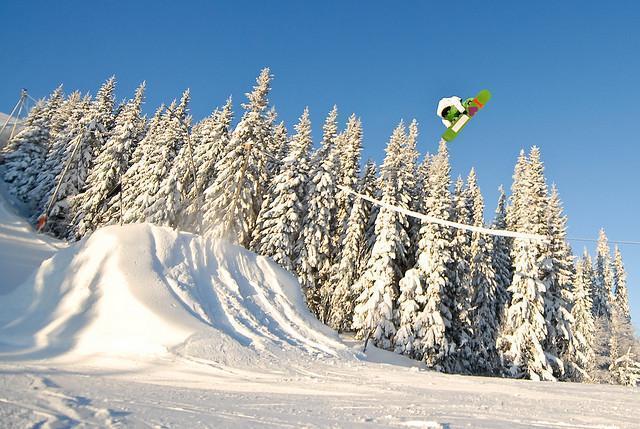How many brown horses are jumping in this photo?
Give a very brief answer. 0. 